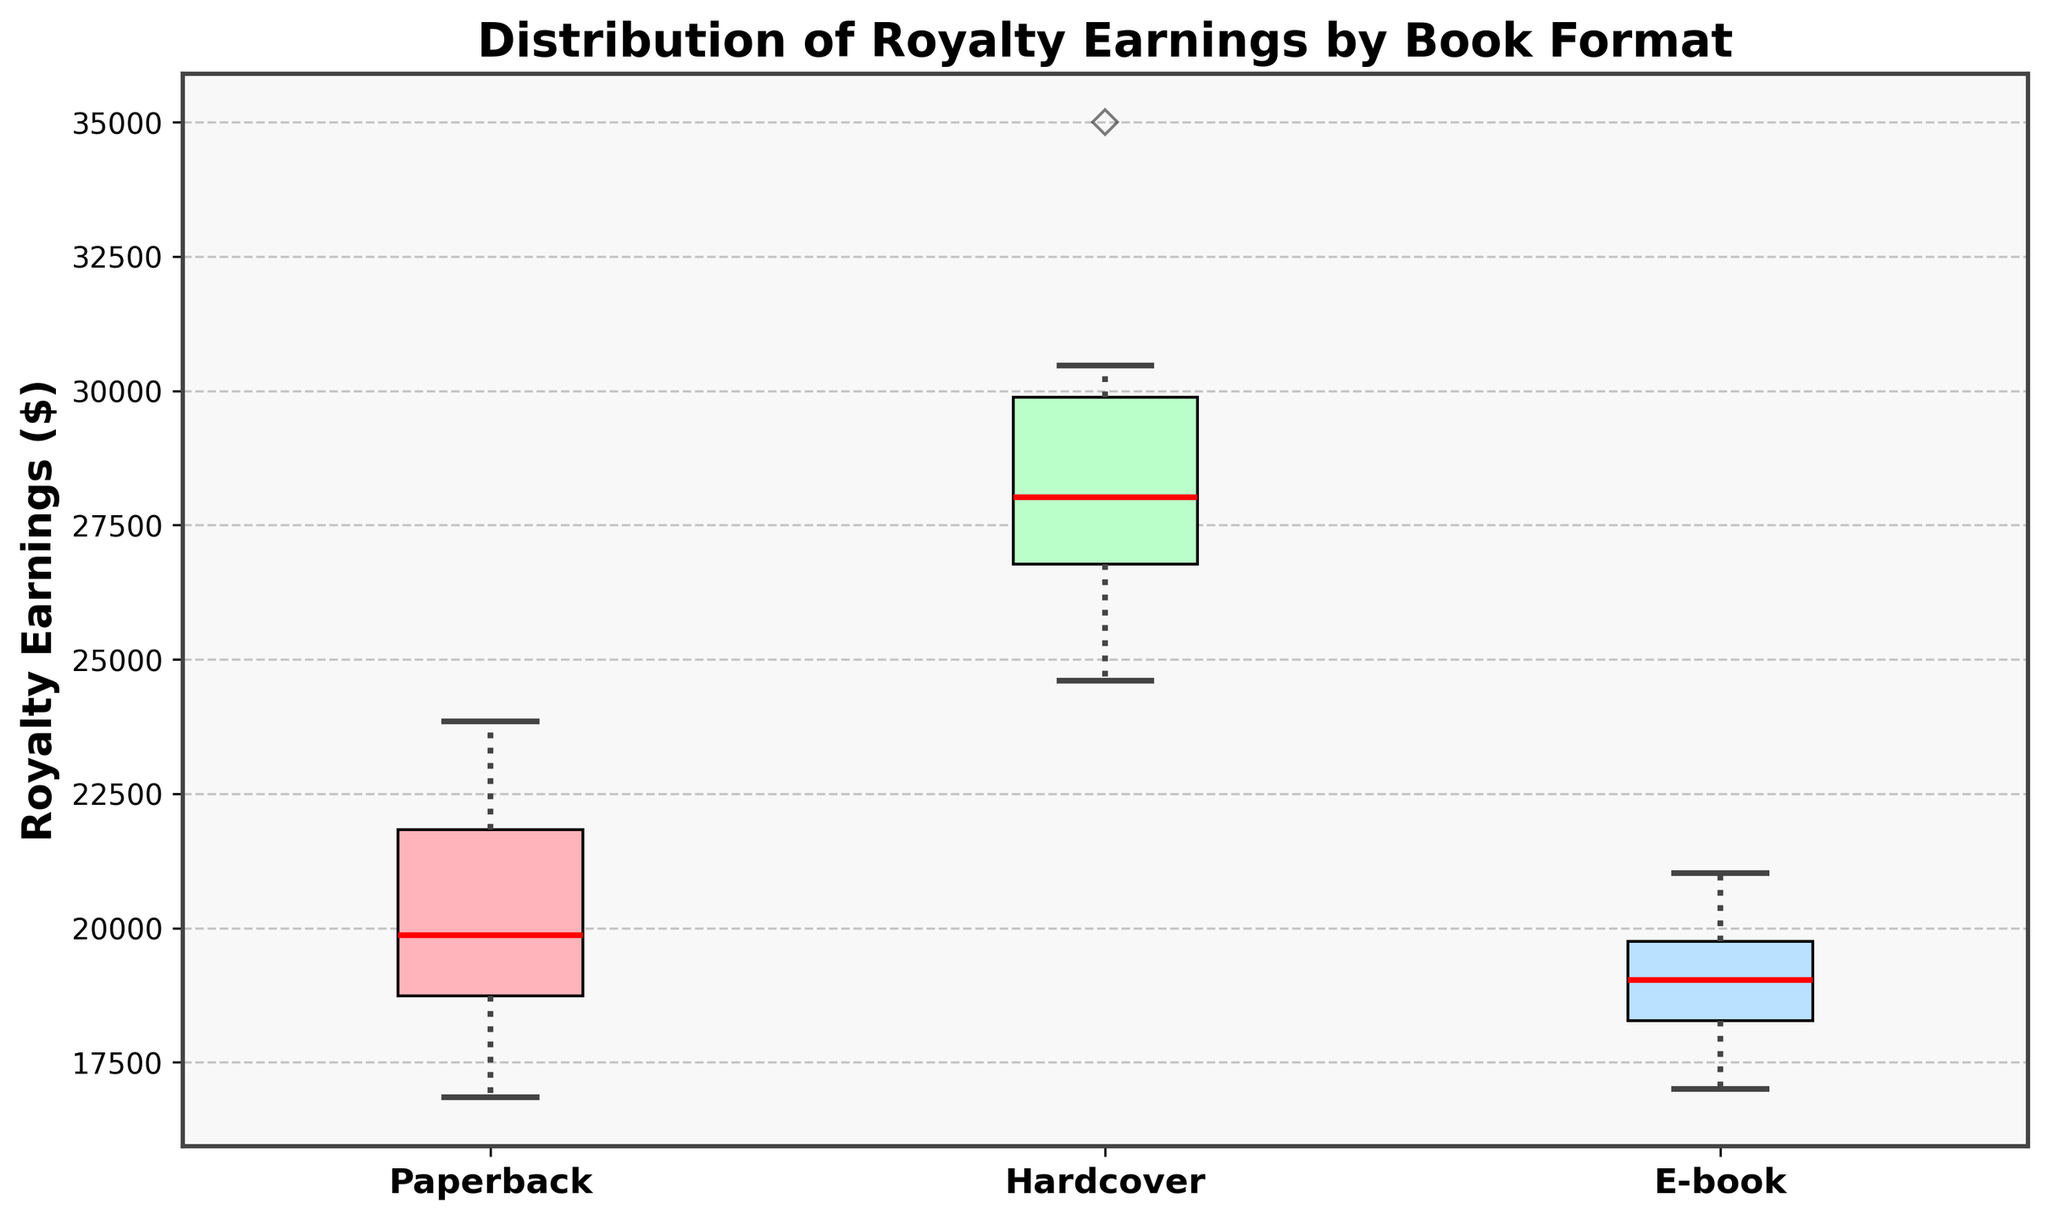What are the different book formats shown in the box plot? The box plot displays three different book formats on the x-axis, labeled as Paperback, Hardcover, and E-book.
Answer: Paperback, Hardcover, E-book Which book format has the highest median royalty earnings? The red line inside each box represents the median salary. By comparing the red lines, the Hardcover format has the highest median earnings.
Answer: Hardcover What is the approximate median royalty earnings for the Paperback format? The red line inside the Paperback box indicates the median. By observing its position along the y-axis, it's around $20,000.
Answer: $20,000 How do the interquartile ranges (IQRs) of the book formats compare? The IQR is the range between the lower and upper bounds of the box. Hardcover has the widest IQR, followed by Paperback, and then E-book with the narrowest IQR.
Answer: Hardcover > Paperback > E-book Which book format has the smallest range of royalty earnings? The range is the distance between the top and bottom whiskers. E-book has the shortest whiskers, indicating the smallest range.
Answer: E-book Is there any format where an individual author stands out more from the others? The presence of fliers (points outside the whiskers) can indicate outliers. Paperback and E-book formats have fliers, implying variation, with Hardcover showing more uniformity but has Stephen King as a notable higher point.
Answer: Paperback, E-book Which format has authors earning around $35,000 in royalties? By observing the y-axis values against each format, Hardcover format has authors who earn around $35,000.
Answer: Hardcover How does the overall distribution of the E-book royalties compare to the Hardcover? The E-book royalties are more tightly clustered, suggesting less variability, while Hardcover has a wider distribution, indicating more variability in earnings.
Answer: Less variable vs. More variable What is the approximate maximum royalty earning for the E-book format? The top whiskers indicate the maximum value. For E-book format, it's slightly above $21,000.
Answer: $21,000 